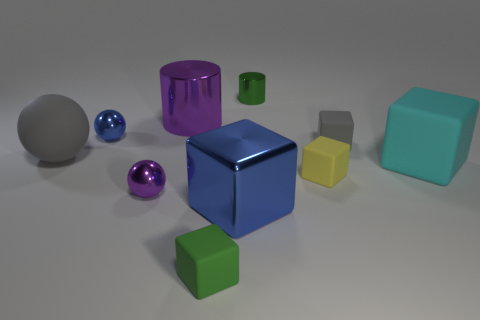Subtract all blue balls. How many balls are left? 2 Subtract all gray cubes. How many cubes are left? 4 Subtract 1 cubes. How many cubes are left? 4 Subtract all brown blocks. Subtract all green cylinders. How many blocks are left? 5 Subtract all spheres. How many objects are left? 7 Add 5 small yellow things. How many small yellow things are left? 6 Add 1 green matte blocks. How many green matte blocks exist? 2 Subtract 1 blue cubes. How many objects are left? 9 Subtract all tiny yellow matte objects. Subtract all shiny things. How many objects are left? 4 